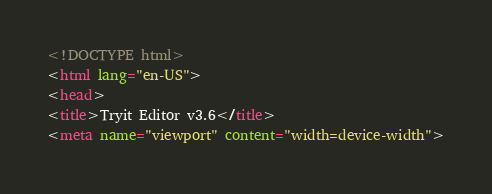<code> <loc_0><loc_0><loc_500><loc_500><_HTML_>
<!DOCTYPE html>
<html lang="en-US">
<head>
<title>Tryit Editor v3.6</title>
<meta name="viewport" content="width=device-width"></code> 